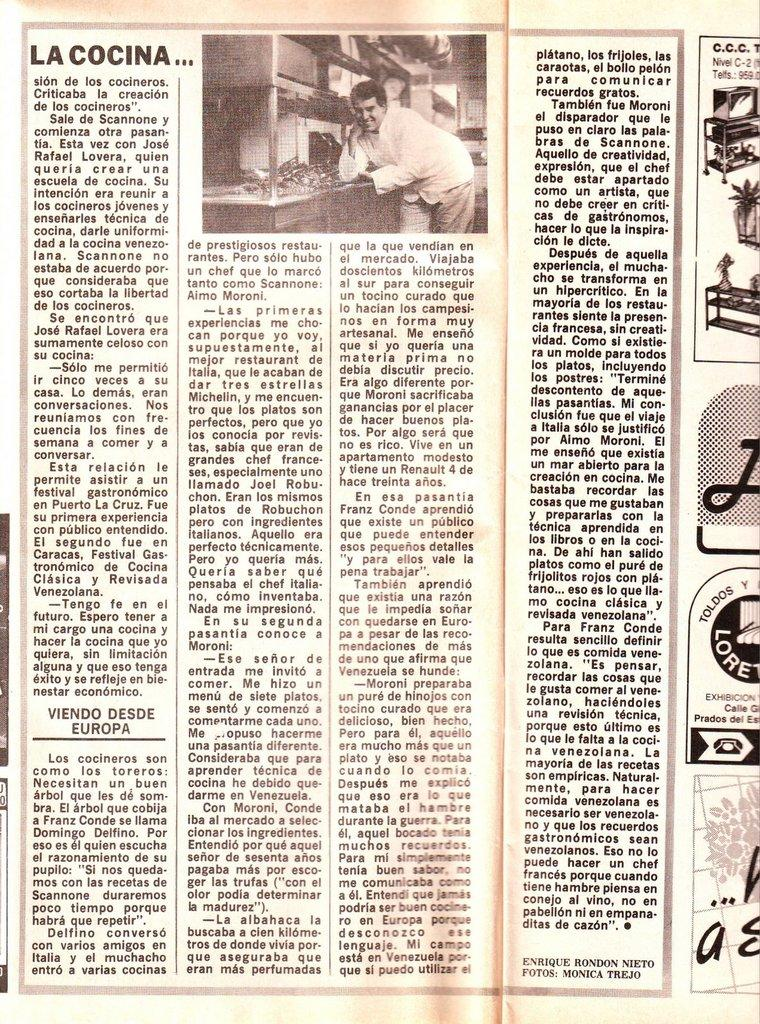What is the main object in the image? There is a newspaper in the image. What can be found on the newspaper? The newspaper has text on it. Who is present in the image? There is a man visible in the image. What is located on the right side of the newspaper? There are pictures on the right side of the newspaper. What type of feather can be seen falling on the newspaper in the image? There is no feather or falling action present in the image; it only features a newspaper with text and pictures, and a man. 